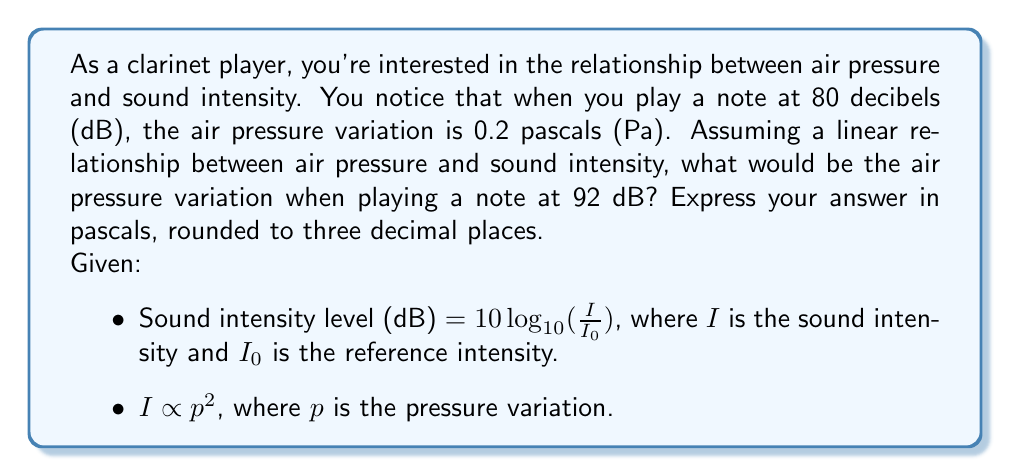Can you solve this math problem? Let's approach this step-by-step:

1) First, we need to understand the relationship between decibels and intensity. The equation for sound intensity level is:

   $L = 10 \log_{10}(\frac{I}{I_0})$

   where $L$ is the sound level in dB, $I$ is the intensity, and $I_0$ is the reference intensity.

2) We're told that intensity is proportional to the square of pressure variation:

   $I \propto p^2$

3) Let's call the initial conditions (80 dB, 0.2 Pa) as $L_1$, $p_1$, and the conditions we're solving for (92 dB, unknown Pa) as $L_2$, $p_2$.

4) We can write the relationship between these two conditions:

   $\frac{I_2}{I_1} = (\frac{p_2}{p_1})^2$

5) We can also write the difference in decibels in terms of this intensity ratio:

   $L_2 - L_1 = 10 \log_{10}(\frac{I_2}{I_1})$

6) Substituting the known values:

   $92 - 80 = 10 \log_{10}(\frac{I_2}{I_1})$

7) Simplifying:

   $12 = 10 \log_{10}(\frac{I_2}{I_1})$

8) Solving for the intensity ratio:

   $\frac{I_2}{I_1} = 10^{1.2} \approx 15.8489$

9) Remember from step 4 that this is equal to $(\frac{p_2}{p_1})^2$. So:

   $(\frac{p_2}{p_1})^2 = 15.8489$

10) Taking the square root of both sides:

    $\frac{p_2}{p_1} = \sqrt{15.8489} \approx 3.9811$

11) Now we can solve for $p_2$:

    $p_2 = 3.9811 \times p_1 = 3.9811 \times 0.2 \approx 0.7962$ Pa

12) Rounding to three decimal places:

    $p_2 \approx 0.796$ Pa
Answer: 0.796 Pa 